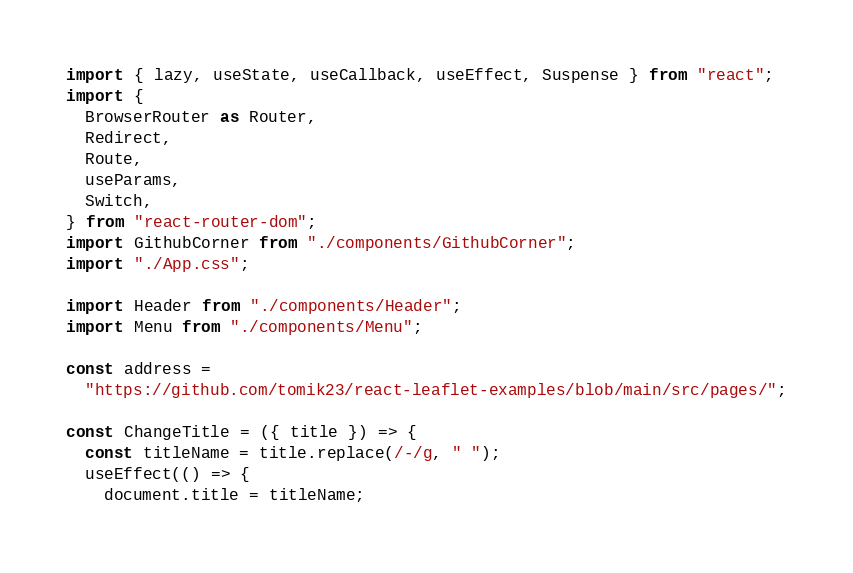<code> <loc_0><loc_0><loc_500><loc_500><_JavaScript_>import { lazy, useState, useCallback, useEffect, Suspense } from "react";
import {
  BrowserRouter as Router,
  Redirect,
  Route,
  useParams,
  Switch,
} from "react-router-dom";
import GithubCorner from "./components/GithubCorner";
import "./App.css";

import Header from "./components/Header";
import Menu from "./components/Menu";

const address =
  "https://github.com/tomik23/react-leaflet-examples/blob/main/src/pages/";

const ChangeTitle = ({ title }) => {
  const titleName = title.replace(/-/g, " ");
  useEffect(() => {
    document.title = titleName;</code> 